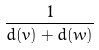<formula> <loc_0><loc_0><loc_500><loc_500>\frac { 1 } { d ( v ) + d ( w ) }</formula> 